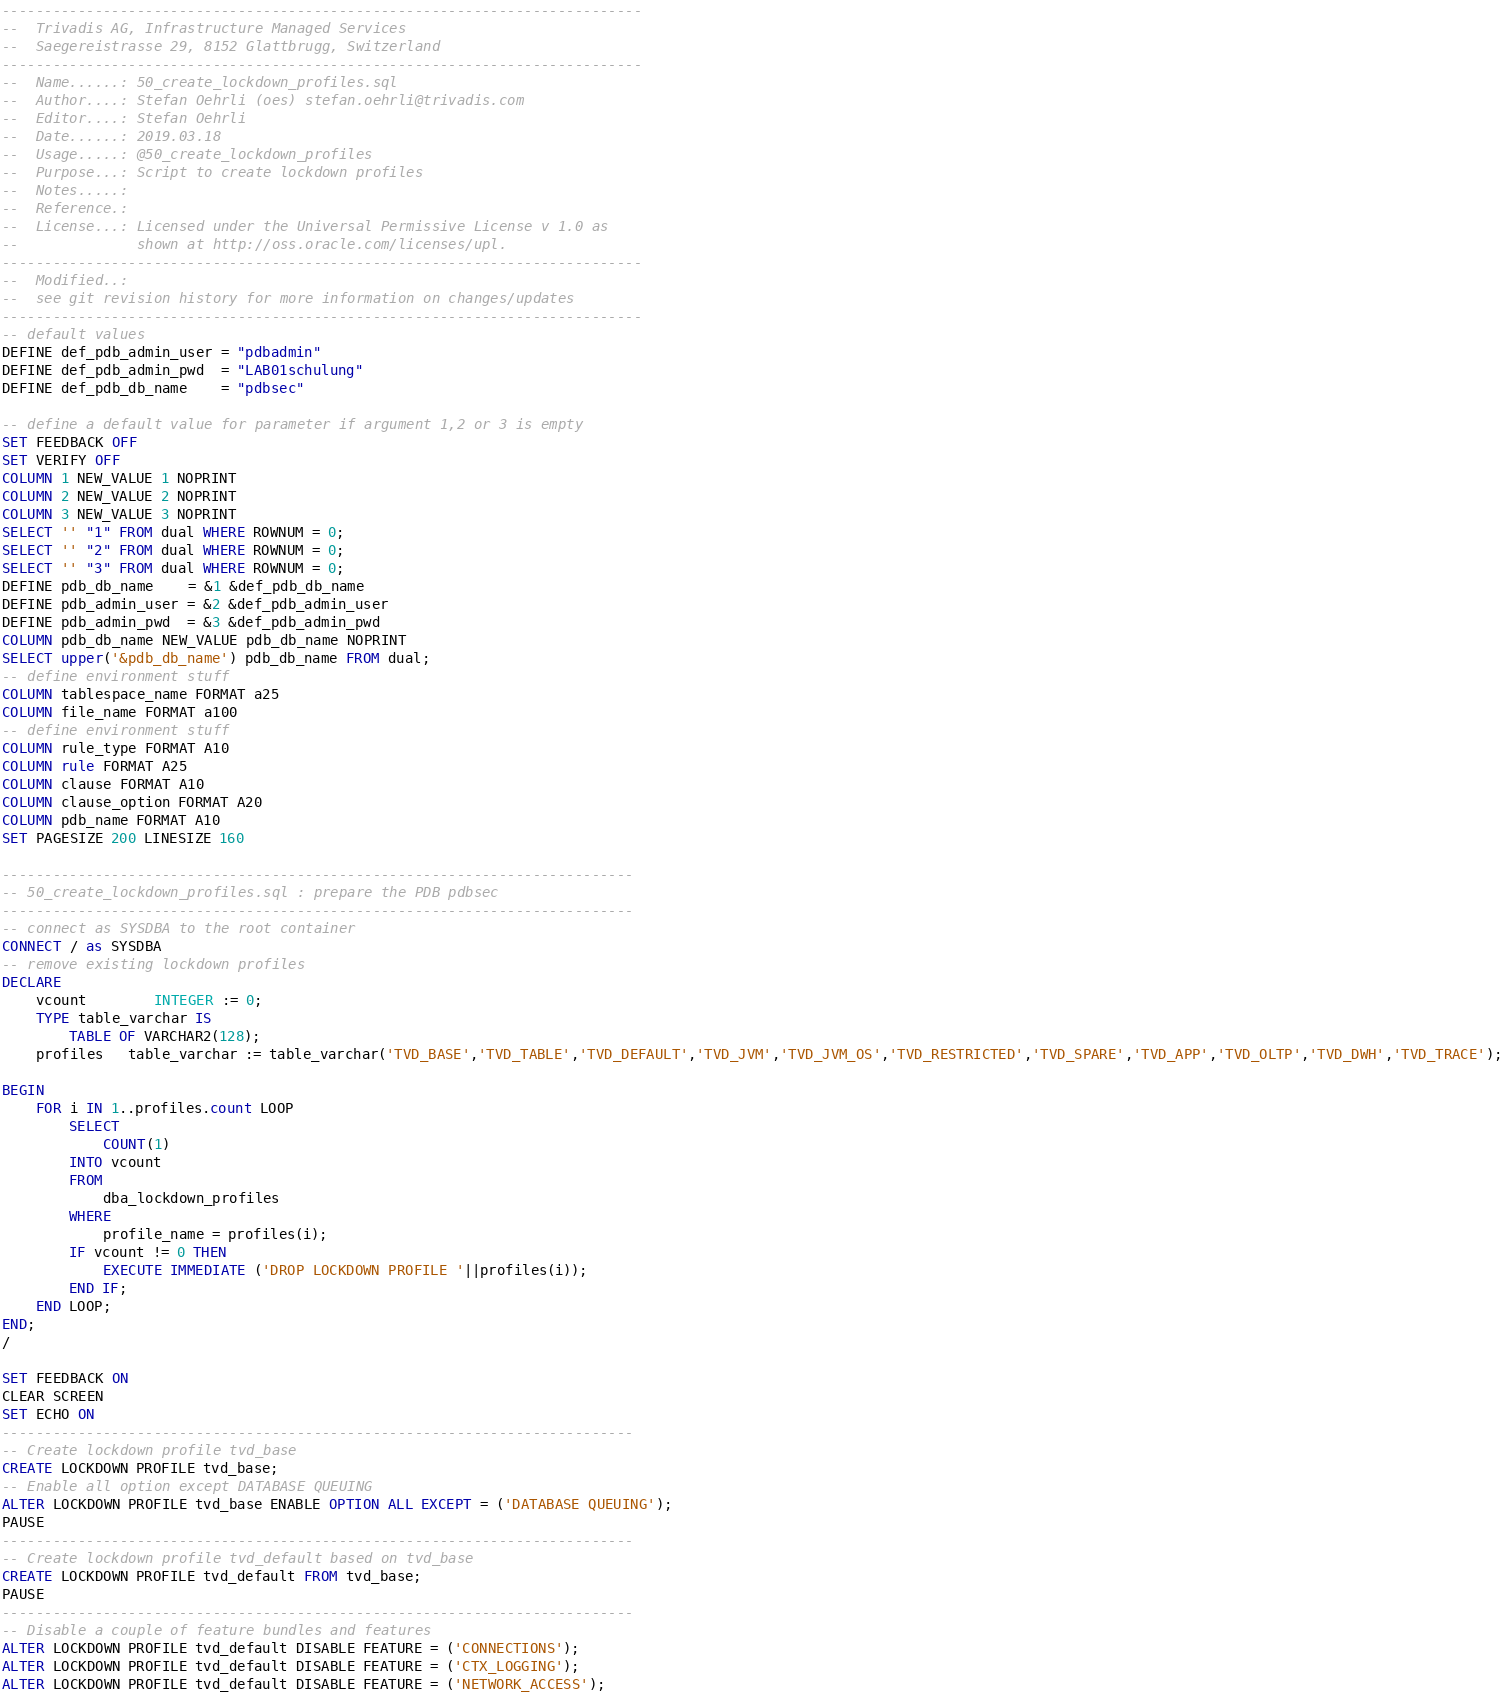<code> <loc_0><loc_0><loc_500><loc_500><_SQL_>----------------------------------------------------------------------------
--  Trivadis AG, Infrastructure Managed Services
--  Saegereistrasse 29, 8152 Glattbrugg, Switzerland
----------------------------------------------------------------------------
--  Name......: 50_create_lockdown_profiles.sql
--  Author....: Stefan Oehrli (oes) stefan.oehrli@trivadis.com
--  Editor....: Stefan Oehrli
--  Date......: 2019.03.18
--  Usage.....: @50_create_lockdown_profiles
--  Purpose...: Script to create lockdown profiles
--  Notes.....: 
--  Reference.: 
--  License...: Licensed under the Universal Permissive License v 1.0 as 
--              shown at http://oss.oracle.com/licenses/upl.
----------------------------------------------------------------------------
--  Modified..:
--  see git revision history for more information on changes/updates
----------------------------------------------------------------------------
-- default values
DEFINE def_pdb_admin_user = "pdbadmin"
DEFINE def_pdb_admin_pwd  = "LAB01schulung"
DEFINE def_pdb_db_name    = "pdbsec"

-- define a default value for parameter if argument 1,2 or 3 is empty
SET FEEDBACK OFF
SET VERIFY OFF
COLUMN 1 NEW_VALUE 1 NOPRINT
COLUMN 2 NEW_VALUE 2 NOPRINT
COLUMN 3 NEW_VALUE 3 NOPRINT
SELECT '' "1" FROM dual WHERE ROWNUM = 0;
SELECT '' "2" FROM dual WHERE ROWNUM = 0;
SELECT '' "3" FROM dual WHERE ROWNUM = 0;
DEFINE pdb_db_name    = &1 &def_pdb_db_name
DEFINE pdb_admin_user = &2 &def_pdb_admin_user
DEFINE pdb_admin_pwd  = &3 &def_pdb_admin_pwd
COLUMN pdb_db_name NEW_VALUE pdb_db_name NOPRINT
SELECT upper('&pdb_db_name') pdb_db_name FROM dual;
-- define environment stuff
COLUMN tablespace_name FORMAT a25
COLUMN file_name FORMAT a100
-- define environment stuff
COLUMN rule_type FORMAT A10
COLUMN rule FORMAT A25
COLUMN clause FORMAT A10
COLUMN clause_option FORMAT A20
COLUMN pdb_name FORMAT A10
SET PAGESIZE 200 LINESIZE 160

---------------------------------------------------------------------------
-- 50_create_lockdown_profiles.sql : prepare the PDB pdbsec
---------------------------------------------------------------------------
-- connect as SYSDBA to the root container
CONNECT / as SYSDBA
-- remove existing lockdown profiles
DECLARE
    vcount        INTEGER := 0;
    TYPE table_varchar IS
        TABLE OF VARCHAR2(128);
    profiles   table_varchar := table_varchar('TVD_BASE','TVD_TABLE','TVD_DEFAULT','TVD_JVM','TVD_JVM_OS','TVD_RESTRICTED','TVD_SPARE','TVD_APP','TVD_OLTP','TVD_DWH','TVD_TRACE');

BEGIN  
    FOR i IN 1..profiles.count LOOP
        SELECT
            COUNT(1)
        INTO vcount
        FROM
            dba_lockdown_profiles
        WHERE
            profile_name = profiles(i);
        IF vcount != 0 THEN
            EXECUTE IMMEDIATE ('DROP LOCKDOWN PROFILE '||profiles(i));
        END IF; 
    END LOOP;
END;
/

SET FEEDBACK ON
CLEAR SCREEN
SET ECHO ON
---------------------------------------------------------------------------
-- Create lockdown profile tvd_base 
CREATE LOCKDOWN PROFILE tvd_base;
-- Enable all option except DATABASE QUEUING
ALTER LOCKDOWN PROFILE tvd_base ENABLE OPTION ALL EXCEPT = ('DATABASE QUEUING');
PAUSE
---------------------------------------------------------------------------
-- Create lockdown profile tvd_default based on tvd_base
CREATE LOCKDOWN PROFILE tvd_default FROM tvd_base;
PAUSE
---------------------------------------------------------------------------
-- Disable a couple of feature bundles and features
ALTER LOCKDOWN PROFILE tvd_default DISABLE FEATURE = ('CONNECTIONS');
ALTER LOCKDOWN PROFILE tvd_default DISABLE FEATURE = ('CTX_LOGGING');
ALTER LOCKDOWN PROFILE tvd_default DISABLE FEATURE = ('NETWORK_ACCESS');</code> 